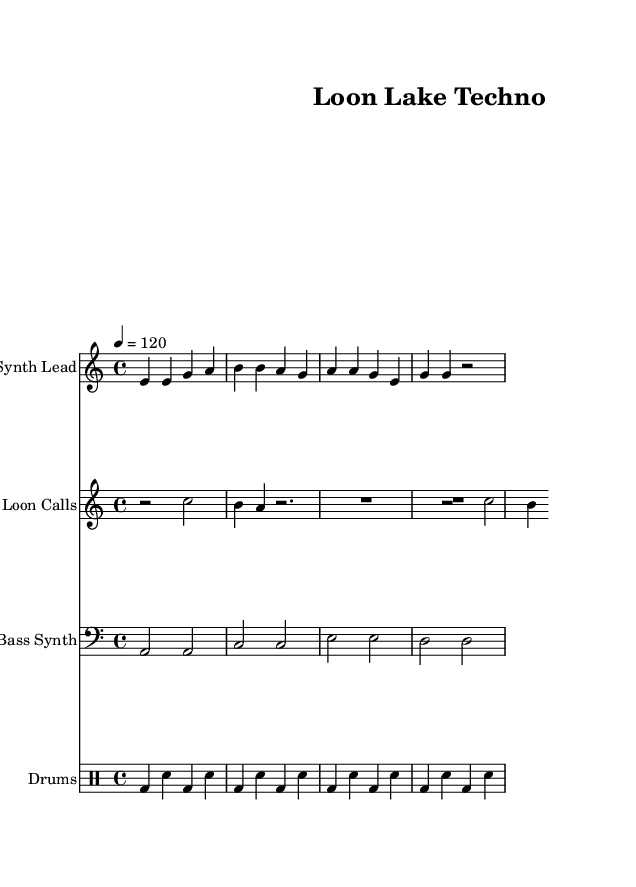What is the key signature of this music? The key signature is A minor, which has no sharps or flats, as indicated by the absence of any sharp or flat symbols at the beginning of the staff.
Answer: A minor What is the time signature of this music? The time signature is 4/4, which is represented by the "4" over "4" in the time signature marking at the beginning of the staff, indicating four beats per measure.
Answer: 4/4 What is the tempo marking for this piece? The tempo marking is 120 beats per minute, indicated by the notation "4 = 120" in the tempo directive at the beginning of the score.
Answer: 120 How many measures are in the synth lead part? The synth lead part contains four measures, as counted from the vertical lines separating each measure in the staff on the sheet music.
Answer: 4 What type of instrument is featured as the "Loon Calls"? The "Loon Calls" is primarily featuring a synthesizer that mimics bird calls, highlighted in the staff labeled accordingly, while the notation represents the desired sounds of loons.
Answer: Synthesizer How many different musical sections are present in this score? There are four distinct musical sections in this score, each indicated by the different staffs labeled "Synth Lead," "Loon Calls," "Bass Synth," and "Drums," denoting unique layers of sound.
Answer: 4 